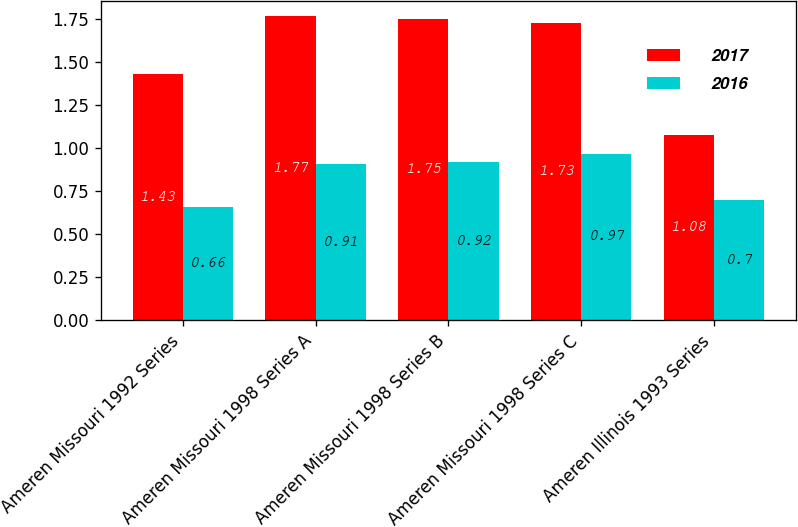Convert chart. <chart><loc_0><loc_0><loc_500><loc_500><stacked_bar_chart><ecel><fcel>Ameren Missouri 1992 Series<fcel>Ameren Missouri 1998 Series A<fcel>Ameren Missouri 1998 Series B<fcel>Ameren Missouri 1998 Series C<fcel>Ameren Illinois 1993 Series<nl><fcel>2017<fcel>1.43<fcel>1.77<fcel>1.75<fcel>1.73<fcel>1.08<nl><fcel>2016<fcel>0.66<fcel>0.91<fcel>0.92<fcel>0.97<fcel>0.7<nl></chart> 